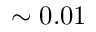<formula> <loc_0><loc_0><loc_500><loc_500>\sim 0 . 0 1</formula> 